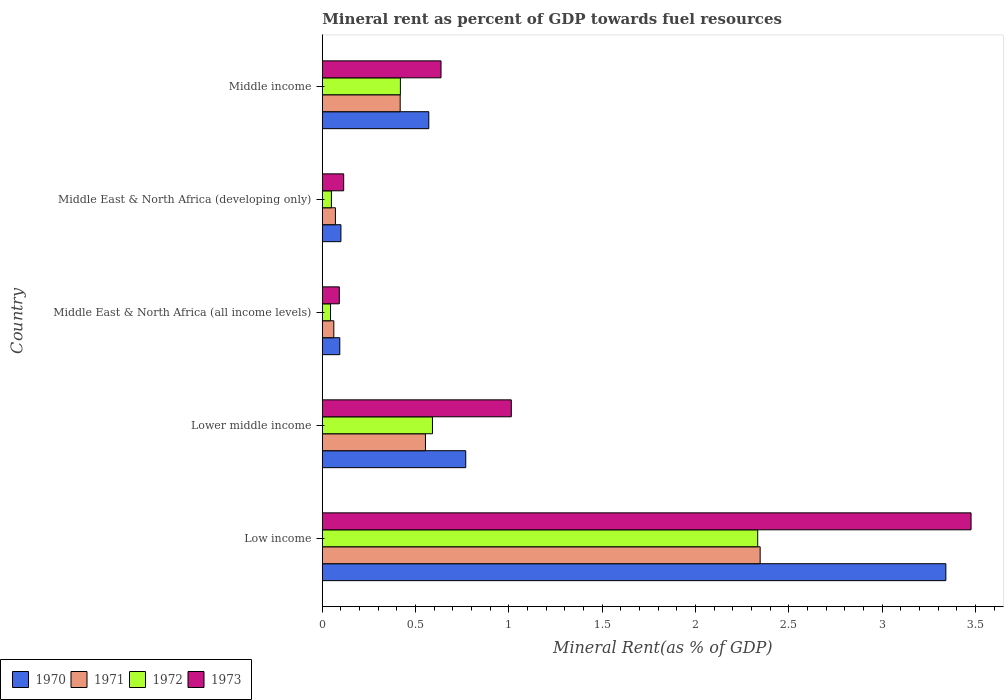How many different coloured bars are there?
Your answer should be very brief. 4. How many bars are there on the 5th tick from the top?
Offer a terse response. 4. How many bars are there on the 1st tick from the bottom?
Offer a very short reply. 4. What is the label of the 3rd group of bars from the top?
Keep it short and to the point. Middle East & North Africa (all income levels). In how many cases, is the number of bars for a given country not equal to the number of legend labels?
Offer a very short reply. 0. What is the mineral rent in 1970 in Middle East & North Africa (all income levels)?
Your answer should be very brief. 0.09. Across all countries, what is the maximum mineral rent in 1972?
Your answer should be very brief. 2.33. Across all countries, what is the minimum mineral rent in 1971?
Keep it short and to the point. 0.06. In which country was the mineral rent in 1972 minimum?
Keep it short and to the point. Middle East & North Africa (all income levels). What is the total mineral rent in 1970 in the graph?
Offer a terse response. 4.87. What is the difference between the mineral rent in 1970 in Lower middle income and that in Middle East & North Africa (all income levels)?
Give a very brief answer. 0.67. What is the difference between the mineral rent in 1971 in Middle income and the mineral rent in 1970 in Middle East & North Africa (developing only)?
Offer a terse response. 0.32. What is the average mineral rent in 1970 per country?
Your answer should be very brief. 0.97. What is the difference between the mineral rent in 1972 and mineral rent in 1971 in Lower middle income?
Provide a succinct answer. 0.04. In how many countries, is the mineral rent in 1971 greater than 0.4 %?
Provide a short and direct response. 3. What is the ratio of the mineral rent in 1973 in Low income to that in Middle East & North Africa (developing only)?
Keep it short and to the point. 30.36. Is the difference between the mineral rent in 1972 in Middle East & North Africa (all income levels) and Middle income greater than the difference between the mineral rent in 1971 in Middle East & North Africa (all income levels) and Middle income?
Provide a succinct answer. No. What is the difference between the highest and the second highest mineral rent in 1972?
Make the answer very short. 1.74. What is the difference between the highest and the lowest mineral rent in 1972?
Your answer should be compact. 2.29. In how many countries, is the mineral rent in 1971 greater than the average mineral rent in 1971 taken over all countries?
Offer a terse response. 1. Is it the case that in every country, the sum of the mineral rent in 1973 and mineral rent in 1970 is greater than the mineral rent in 1972?
Give a very brief answer. Yes. How many countries are there in the graph?
Your response must be concise. 5. What is the difference between two consecutive major ticks on the X-axis?
Offer a terse response. 0.5. How many legend labels are there?
Your answer should be very brief. 4. What is the title of the graph?
Make the answer very short. Mineral rent as percent of GDP towards fuel resources. What is the label or title of the X-axis?
Provide a succinct answer. Mineral Rent(as % of GDP). What is the label or title of the Y-axis?
Make the answer very short. Country. What is the Mineral Rent(as % of GDP) in 1970 in Low income?
Provide a succinct answer. 3.34. What is the Mineral Rent(as % of GDP) of 1971 in Low income?
Offer a terse response. 2.35. What is the Mineral Rent(as % of GDP) of 1972 in Low income?
Your response must be concise. 2.33. What is the Mineral Rent(as % of GDP) in 1973 in Low income?
Provide a succinct answer. 3.48. What is the Mineral Rent(as % of GDP) in 1970 in Lower middle income?
Give a very brief answer. 0.77. What is the Mineral Rent(as % of GDP) in 1971 in Lower middle income?
Your response must be concise. 0.55. What is the Mineral Rent(as % of GDP) of 1972 in Lower middle income?
Your answer should be very brief. 0.59. What is the Mineral Rent(as % of GDP) of 1973 in Lower middle income?
Ensure brevity in your answer.  1.01. What is the Mineral Rent(as % of GDP) of 1970 in Middle East & North Africa (all income levels)?
Your answer should be very brief. 0.09. What is the Mineral Rent(as % of GDP) of 1971 in Middle East & North Africa (all income levels)?
Your response must be concise. 0.06. What is the Mineral Rent(as % of GDP) of 1972 in Middle East & North Africa (all income levels)?
Give a very brief answer. 0.04. What is the Mineral Rent(as % of GDP) in 1973 in Middle East & North Africa (all income levels)?
Make the answer very short. 0.09. What is the Mineral Rent(as % of GDP) in 1970 in Middle East & North Africa (developing only)?
Ensure brevity in your answer.  0.1. What is the Mineral Rent(as % of GDP) of 1971 in Middle East & North Africa (developing only)?
Your answer should be very brief. 0.07. What is the Mineral Rent(as % of GDP) in 1972 in Middle East & North Africa (developing only)?
Your answer should be compact. 0.05. What is the Mineral Rent(as % of GDP) of 1973 in Middle East & North Africa (developing only)?
Provide a short and direct response. 0.11. What is the Mineral Rent(as % of GDP) in 1970 in Middle income?
Provide a short and direct response. 0.57. What is the Mineral Rent(as % of GDP) of 1971 in Middle income?
Give a very brief answer. 0.42. What is the Mineral Rent(as % of GDP) in 1972 in Middle income?
Offer a very short reply. 0.42. What is the Mineral Rent(as % of GDP) in 1973 in Middle income?
Make the answer very short. 0.64. Across all countries, what is the maximum Mineral Rent(as % of GDP) in 1970?
Provide a succinct answer. 3.34. Across all countries, what is the maximum Mineral Rent(as % of GDP) in 1971?
Provide a succinct answer. 2.35. Across all countries, what is the maximum Mineral Rent(as % of GDP) of 1972?
Offer a terse response. 2.33. Across all countries, what is the maximum Mineral Rent(as % of GDP) in 1973?
Ensure brevity in your answer.  3.48. Across all countries, what is the minimum Mineral Rent(as % of GDP) of 1970?
Provide a succinct answer. 0.09. Across all countries, what is the minimum Mineral Rent(as % of GDP) in 1971?
Provide a short and direct response. 0.06. Across all countries, what is the minimum Mineral Rent(as % of GDP) of 1972?
Give a very brief answer. 0.04. Across all countries, what is the minimum Mineral Rent(as % of GDP) of 1973?
Your answer should be compact. 0.09. What is the total Mineral Rent(as % of GDP) of 1970 in the graph?
Your answer should be compact. 4.87. What is the total Mineral Rent(as % of GDP) of 1971 in the graph?
Offer a terse response. 3.45. What is the total Mineral Rent(as % of GDP) of 1972 in the graph?
Offer a terse response. 3.43. What is the total Mineral Rent(as % of GDP) of 1973 in the graph?
Your answer should be very brief. 5.33. What is the difference between the Mineral Rent(as % of GDP) in 1970 in Low income and that in Lower middle income?
Ensure brevity in your answer.  2.57. What is the difference between the Mineral Rent(as % of GDP) of 1971 in Low income and that in Lower middle income?
Give a very brief answer. 1.79. What is the difference between the Mineral Rent(as % of GDP) in 1972 in Low income and that in Lower middle income?
Provide a short and direct response. 1.74. What is the difference between the Mineral Rent(as % of GDP) of 1973 in Low income and that in Lower middle income?
Your response must be concise. 2.46. What is the difference between the Mineral Rent(as % of GDP) of 1970 in Low income and that in Middle East & North Africa (all income levels)?
Give a very brief answer. 3.25. What is the difference between the Mineral Rent(as % of GDP) in 1971 in Low income and that in Middle East & North Africa (all income levels)?
Your answer should be very brief. 2.28. What is the difference between the Mineral Rent(as % of GDP) of 1972 in Low income and that in Middle East & North Africa (all income levels)?
Provide a short and direct response. 2.29. What is the difference between the Mineral Rent(as % of GDP) of 1973 in Low income and that in Middle East & North Africa (all income levels)?
Keep it short and to the point. 3.39. What is the difference between the Mineral Rent(as % of GDP) of 1970 in Low income and that in Middle East & North Africa (developing only)?
Give a very brief answer. 3.24. What is the difference between the Mineral Rent(as % of GDP) in 1971 in Low income and that in Middle East & North Africa (developing only)?
Provide a succinct answer. 2.28. What is the difference between the Mineral Rent(as % of GDP) in 1972 in Low income and that in Middle East & North Africa (developing only)?
Your response must be concise. 2.28. What is the difference between the Mineral Rent(as % of GDP) of 1973 in Low income and that in Middle East & North Africa (developing only)?
Provide a succinct answer. 3.36. What is the difference between the Mineral Rent(as % of GDP) of 1970 in Low income and that in Middle income?
Your answer should be very brief. 2.77. What is the difference between the Mineral Rent(as % of GDP) of 1971 in Low income and that in Middle income?
Your answer should be compact. 1.93. What is the difference between the Mineral Rent(as % of GDP) in 1972 in Low income and that in Middle income?
Your response must be concise. 1.91. What is the difference between the Mineral Rent(as % of GDP) in 1973 in Low income and that in Middle income?
Your answer should be very brief. 2.84. What is the difference between the Mineral Rent(as % of GDP) in 1970 in Lower middle income and that in Middle East & North Africa (all income levels)?
Give a very brief answer. 0.67. What is the difference between the Mineral Rent(as % of GDP) of 1971 in Lower middle income and that in Middle East & North Africa (all income levels)?
Offer a terse response. 0.49. What is the difference between the Mineral Rent(as % of GDP) in 1972 in Lower middle income and that in Middle East & North Africa (all income levels)?
Offer a terse response. 0.55. What is the difference between the Mineral Rent(as % of GDP) of 1973 in Lower middle income and that in Middle East & North Africa (all income levels)?
Ensure brevity in your answer.  0.92. What is the difference between the Mineral Rent(as % of GDP) of 1970 in Lower middle income and that in Middle East & North Africa (developing only)?
Make the answer very short. 0.67. What is the difference between the Mineral Rent(as % of GDP) of 1971 in Lower middle income and that in Middle East & North Africa (developing only)?
Your response must be concise. 0.48. What is the difference between the Mineral Rent(as % of GDP) of 1972 in Lower middle income and that in Middle East & North Africa (developing only)?
Ensure brevity in your answer.  0.54. What is the difference between the Mineral Rent(as % of GDP) of 1973 in Lower middle income and that in Middle East & North Africa (developing only)?
Provide a succinct answer. 0.9. What is the difference between the Mineral Rent(as % of GDP) of 1970 in Lower middle income and that in Middle income?
Ensure brevity in your answer.  0.2. What is the difference between the Mineral Rent(as % of GDP) of 1971 in Lower middle income and that in Middle income?
Your answer should be compact. 0.14. What is the difference between the Mineral Rent(as % of GDP) in 1972 in Lower middle income and that in Middle income?
Provide a short and direct response. 0.17. What is the difference between the Mineral Rent(as % of GDP) of 1973 in Lower middle income and that in Middle income?
Ensure brevity in your answer.  0.38. What is the difference between the Mineral Rent(as % of GDP) of 1970 in Middle East & North Africa (all income levels) and that in Middle East & North Africa (developing only)?
Your answer should be very brief. -0.01. What is the difference between the Mineral Rent(as % of GDP) in 1971 in Middle East & North Africa (all income levels) and that in Middle East & North Africa (developing only)?
Provide a succinct answer. -0.01. What is the difference between the Mineral Rent(as % of GDP) in 1972 in Middle East & North Africa (all income levels) and that in Middle East & North Africa (developing only)?
Keep it short and to the point. -0. What is the difference between the Mineral Rent(as % of GDP) of 1973 in Middle East & North Africa (all income levels) and that in Middle East & North Africa (developing only)?
Offer a terse response. -0.02. What is the difference between the Mineral Rent(as % of GDP) in 1970 in Middle East & North Africa (all income levels) and that in Middle income?
Offer a terse response. -0.48. What is the difference between the Mineral Rent(as % of GDP) of 1971 in Middle East & North Africa (all income levels) and that in Middle income?
Your answer should be compact. -0.36. What is the difference between the Mineral Rent(as % of GDP) of 1972 in Middle East & North Africa (all income levels) and that in Middle income?
Offer a very short reply. -0.37. What is the difference between the Mineral Rent(as % of GDP) of 1973 in Middle East & North Africa (all income levels) and that in Middle income?
Offer a very short reply. -0.55. What is the difference between the Mineral Rent(as % of GDP) in 1970 in Middle East & North Africa (developing only) and that in Middle income?
Ensure brevity in your answer.  -0.47. What is the difference between the Mineral Rent(as % of GDP) of 1971 in Middle East & North Africa (developing only) and that in Middle income?
Ensure brevity in your answer.  -0.35. What is the difference between the Mineral Rent(as % of GDP) in 1972 in Middle East & North Africa (developing only) and that in Middle income?
Your answer should be very brief. -0.37. What is the difference between the Mineral Rent(as % of GDP) in 1973 in Middle East & North Africa (developing only) and that in Middle income?
Provide a short and direct response. -0.52. What is the difference between the Mineral Rent(as % of GDP) in 1970 in Low income and the Mineral Rent(as % of GDP) in 1971 in Lower middle income?
Offer a terse response. 2.79. What is the difference between the Mineral Rent(as % of GDP) of 1970 in Low income and the Mineral Rent(as % of GDP) of 1972 in Lower middle income?
Ensure brevity in your answer.  2.75. What is the difference between the Mineral Rent(as % of GDP) in 1970 in Low income and the Mineral Rent(as % of GDP) in 1973 in Lower middle income?
Give a very brief answer. 2.33. What is the difference between the Mineral Rent(as % of GDP) of 1971 in Low income and the Mineral Rent(as % of GDP) of 1972 in Lower middle income?
Ensure brevity in your answer.  1.76. What is the difference between the Mineral Rent(as % of GDP) of 1971 in Low income and the Mineral Rent(as % of GDP) of 1973 in Lower middle income?
Ensure brevity in your answer.  1.33. What is the difference between the Mineral Rent(as % of GDP) in 1972 in Low income and the Mineral Rent(as % of GDP) in 1973 in Lower middle income?
Give a very brief answer. 1.32. What is the difference between the Mineral Rent(as % of GDP) in 1970 in Low income and the Mineral Rent(as % of GDP) in 1971 in Middle East & North Africa (all income levels)?
Keep it short and to the point. 3.28. What is the difference between the Mineral Rent(as % of GDP) in 1970 in Low income and the Mineral Rent(as % of GDP) in 1972 in Middle East & North Africa (all income levels)?
Provide a short and direct response. 3.3. What is the difference between the Mineral Rent(as % of GDP) of 1970 in Low income and the Mineral Rent(as % of GDP) of 1973 in Middle East & North Africa (all income levels)?
Your answer should be compact. 3.25. What is the difference between the Mineral Rent(as % of GDP) in 1971 in Low income and the Mineral Rent(as % of GDP) in 1972 in Middle East & North Africa (all income levels)?
Your answer should be very brief. 2.3. What is the difference between the Mineral Rent(as % of GDP) of 1971 in Low income and the Mineral Rent(as % of GDP) of 1973 in Middle East & North Africa (all income levels)?
Your answer should be very brief. 2.26. What is the difference between the Mineral Rent(as % of GDP) in 1972 in Low income and the Mineral Rent(as % of GDP) in 1973 in Middle East & North Africa (all income levels)?
Your answer should be compact. 2.24. What is the difference between the Mineral Rent(as % of GDP) of 1970 in Low income and the Mineral Rent(as % of GDP) of 1971 in Middle East & North Africa (developing only)?
Provide a short and direct response. 3.27. What is the difference between the Mineral Rent(as % of GDP) in 1970 in Low income and the Mineral Rent(as % of GDP) in 1972 in Middle East & North Africa (developing only)?
Keep it short and to the point. 3.29. What is the difference between the Mineral Rent(as % of GDP) in 1970 in Low income and the Mineral Rent(as % of GDP) in 1973 in Middle East & North Africa (developing only)?
Offer a terse response. 3.23. What is the difference between the Mineral Rent(as % of GDP) of 1971 in Low income and the Mineral Rent(as % of GDP) of 1972 in Middle East & North Africa (developing only)?
Keep it short and to the point. 2.3. What is the difference between the Mineral Rent(as % of GDP) of 1971 in Low income and the Mineral Rent(as % of GDP) of 1973 in Middle East & North Africa (developing only)?
Offer a terse response. 2.23. What is the difference between the Mineral Rent(as % of GDP) in 1972 in Low income and the Mineral Rent(as % of GDP) in 1973 in Middle East & North Africa (developing only)?
Make the answer very short. 2.22. What is the difference between the Mineral Rent(as % of GDP) of 1970 in Low income and the Mineral Rent(as % of GDP) of 1971 in Middle income?
Offer a very short reply. 2.92. What is the difference between the Mineral Rent(as % of GDP) of 1970 in Low income and the Mineral Rent(as % of GDP) of 1972 in Middle income?
Offer a terse response. 2.92. What is the difference between the Mineral Rent(as % of GDP) of 1970 in Low income and the Mineral Rent(as % of GDP) of 1973 in Middle income?
Keep it short and to the point. 2.71. What is the difference between the Mineral Rent(as % of GDP) of 1971 in Low income and the Mineral Rent(as % of GDP) of 1972 in Middle income?
Provide a succinct answer. 1.93. What is the difference between the Mineral Rent(as % of GDP) of 1971 in Low income and the Mineral Rent(as % of GDP) of 1973 in Middle income?
Keep it short and to the point. 1.71. What is the difference between the Mineral Rent(as % of GDP) of 1972 in Low income and the Mineral Rent(as % of GDP) of 1973 in Middle income?
Your answer should be compact. 1.7. What is the difference between the Mineral Rent(as % of GDP) in 1970 in Lower middle income and the Mineral Rent(as % of GDP) in 1971 in Middle East & North Africa (all income levels)?
Your response must be concise. 0.71. What is the difference between the Mineral Rent(as % of GDP) in 1970 in Lower middle income and the Mineral Rent(as % of GDP) in 1972 in Middle East & North Africa (all income levels)?
Ensure brevity in your answer.  0.72. What is the difference between the Mineral Rent(as % of GDP) of 1970 in Lower middle income and the Mineral Rent(as % of GDP) of 1973 in Middle East & North Africa (all income levels)?
Give a very brief answer. 0.68. What is the difference between the Mineral Rent(as % of GDP) in 1971 in Lower middle income and the Mineral Rent(as % of GDP) in 1972 in Middle East & North Africa (all income levels)?
Your answer should be compact. 0.51. What is the difference between the Mineral Rent(as % of GDP) in 1971 in Lower middle income and the Mineral Rent(as % of GDP) in 1973 in Middle East & North Africa (all income levels)?
Keep it short and to the point. 0.46. What is the difference between the Mineral Rent(as % of GDP) in 1972 in Lower middle income and the Mineral Rent(as % of GDP) in 1973 in Middle East & North Africa (all income levels)?
Make the answer very short. 0.5. What is the difference between the Mineral Rent(as % of GDP) of 1970 in Lower middle income and the Mineral Rent(as % of GDP) of 1971 in Middle East & North Africa (developing only)?
Offer a very short reply. 0.7. What is the difference between the Mineral Rent(as % of GDP) of 1970 in Lower middle income and the Mineral Rent(as % of GDP) of 1972 in Middle East & North Africa (developing only)?
Give a very brief answer. 0.72. What is the difference between the Mineral Rent(as % of GDP) of 1970 in Lower middle income and the Mineral Rent(as % of GDP) of 1973 in Middle East & North Africa (developing only)?
Offer a very short reply. 0.65. What is the difference between the Mineral Rent(as % of GDP) in 1971 in Lower middle income and the Mineral Rent(as % of GDP) in 1972 in Middle East & North Africa (developing only)?
Make the answer very short. 0.5. What is the difference between the Mineral Rent(as % of GDP) in 1971 in Lower middle income and the Mineral Rent(as % of GDP) in 1973 in Middle East & North Africa (developing only)?
Provide a succinct answer. 0.44. What is the difference between the Mineral Rent(as % of GDP) in 1972 in Lower middle income and the Mineral Rent(as % of GDP) in 1973 in Middle East & North Africa (developing only)?
Your answer should be compact. 0.48. What is the difference between the Mineral Rent(as % of GDP) of 1970 in Lower middle income and the Mineral Rent(as % of GDP) of 1971 in Middle income?
Provide a short and direct response. 0.35. What is the difference between the Mineral Rent(as % of GDP) of 1970 in Lower middle income and the Mineral Rent(as % of GDP) of 1972 in Middle income?
Ensure brevity in your answer.  0.35. What is the difference between the Mineral Rent(as % of GDP) of 1970 in Lower middle income and the Mineral Rent(as % of GDP) of 1973 in Middle income?
Your answer should be very brief. 0.13. What is the difference between the Mineral Rent(as % of GDP) of 1971 in Lower middle income and the Mineral Rent(as % of GDP) of 1972 in Middle income?
Offer a very short reply. 0.13. What is the difference between the Mineral Rent(as % of GDP) of 1971 in Lower middle income and the Mineral Rent(as % of GDP) of 1973 in Middle income?
Give a very brief answer. -0.08. What is the difference between the Mineral Rent(as % of GDP) of 1972 in Lower middle income and the Mineral Rent(as % of GDP) of 1973 in Middle income?
Keep it short and to the point. -0.05. What is the difference between the Mineral Rent(as % of GDP) of 1970 in Middle East & North Africa (all income levels) and the Mineral Rent(as % of GDP) of 1971 in Middle East & North Africa (developing only)?
Your answer should be compact. 0.02. What is the difference between the Mineral Rent(as % of GDP) of 1970 in Middle East & North Africa (all income levels) and the Mineral Rent(as % of GDP) of 1972 in Middle East & North Africa (developing only)?
Your answer should be very brief. 0.04. What is the difference between the Mineral Rent(as % of GDP) of 1970 in Middle East & North Africa (all income levels) and the Mineral Rent(as % of GDP) of 1973 in Middle East & North Africa (developing only)?
Your response must be concise. -0.02. What is the difference between the Mineral Rent(as % of GDP) in 1971 in Middle East & North Africa (all income levels) and the Mineral Rent(as % of GDP) in 1972 in Middle East & North Africa (developing only)?
Your answer should be compact. 0.01. What is the difference between the Mineral Rent(as % of GDP) in 1971 in Middle East & North Africa (all income levels) and the Mineral Rent(as % of GDP) in 1973 in Middle East & North Africa (developing only)?
Offer a terse response. -0.05. What is the difference between the Mineral Rent(as % of GDP) in 1972 in Middle East & North Africa (all income levels) and the Mineral Rent(as % of GDP) in 1973 in Middle East & North Africa (developing only)?
Provide a short and direct response. -0.07. What is the difference between the Mineral Rent(as % of GDP) in 1970 in Middle East & North Africa (all income levels) and the Mineral Rent(as % of GDP) in 1971 in Middle income?
Provide a succinct answer. -0.32. What is the difference between the Mineral Rent(as % of GDP) in 1970 in Middle East & North Africa (all income levels) and the Mineral Rent(as % of GDP) in 1972 in Middle income?
Ensure brevity in your answer.  -0.32. What is the difference between the Mineral Rent(as % of GDP) of 1970 in Middle East & North Africa (all income levels) and the Mineral Rent(as % of GDP) of 1973 in Middle income?
Provide a short and direct response. -0.54. What is the difference between the Mineral Rent(as % of GDP) in 1971 in Middle East & North Africa (all income levels) and the Mineral Rent(as % of GDP) in 1972 in Middle income?
Your answer should be compact. -0.36. What is the difference between the Mineral Rent(as % of GDP) of 1971 in Middle East & North Africa (all income levels) and the Mineral Rent(as % of GDP) of 1973 in Middle income?
Ensure brevity in your answer.  -0.57. What is the difference between the Mineral Rent(as % of GDP) in 1972 in Middle East & North Africa (all income levels) and the Mineral Rent(as % of GDP) in 1973 in Middle income?
Give a very brief answer. -0.59. What is the difference between the Mineral Rent(as % of GDP) of 1970 in Middle East & North Africa (developing only) and the Mineral Rent(as % of GDP) of 1971 in Middle income?
Your answer should be very brief. -0.32. What is the difference between the Mineral Rent(as % of GDP) of 1970 in Middle East & North Africa (developing only) and the Mineral Rent(as % of GDP) of 1972 in Middle income?
Provide a short and direct response. -0.32. What is the difference between the Mineral Rent(as % of GDP) of 1970 in Middle East & North Africa (developing only) and the Mineral Rent(as % of GDP) of 1973 in Middle income?
Your answer should be very brief. -0.54. What is the difference between the Mineral Rent(as % of GDP) in 1971 in Middle East & North Africa (developing only) and the Mineral Rent(as % of GDP) in 1972 in Middle income?
Your answer should be compact. -0.35. What is the difference between the Mineral Rent(as % of GDP) in 1971 in Middle East & North Africa (developing only) and the Mineral Rent(as % of GDP) in 1973 in Middle income?
Give a very brief answer. -0.57. What is the difference between the Mineral Rent(as % of GDP) of 1972 in Middle East & North Africa (developing only) and the Mineral Rent(as % of GDP) of 1973 in Middle income?
Offer a very short reply. -0.59. What is the average Mineral Rent(as % of GDP) of 1970 per country?
Your answer should be very brief. 0.97. What is the average Mineral Rent(as % of GDP) in 1971 per country?
Your response must be concise. 0.69. What is the average Mineral Rent(as % of GDP) in 1972 per country?
Offer a terse response. 0.69. What is the average Mineral Rent(as % of GDP) in 1973 per country?
Offer a very short reply. 1.07. What is the difference between the Mineral Rent(as % of GDP) of 1970 and Mineral Rent(as % of GDP) of 1972 in Low income?
Ensure brevity in your answer.  1.01. What is the difference between the Mineral Rent(as % of GDP) in 1970 and Mineral Rent(as % of GDP) in 1973 in Low income?
Give a very brief answer. -0.14. What is the difference between the Mineral Rent(as % of GDP) in 1971 and Mineral Rent(as % of GDP) in 1972 in Low income?
Your answer should be very brief. 0.01. What is the difference between the Mineral Rent(as % of GDP) in 1971 and Mineral Rent(as % of GDP) in 1973 in Low income?
Make the answer very short. -1.13. What is the difference between the Mineral Rent(as % of GDP) of 1972 and Mineral Rent(as % of GDP) of 1973 in Low income?
Give a very brief answer. -1.14. What is the difference between the Mineral Rent(as % of GDP) in 1970 and Mineral Rent(as % of GDP) in 1971 in Lower middle income?
Give a very brief answer. 0.22. What is the difference between the Mineral Rent(as % of GDP) in 1970 and Mineral Rent(as % of GDP) in 1972 in Lower middle income?
Provide a succinct answer. 0.18. What is the difference between the Mineral Rent(as % of GDP) in 1970 and Mineral Rent(as % of GDP) in 1973 in Lower middle income?
Offer a very short reply. -0.24. What is the difference between the Mineral Rent(as % of GDP) in 1971 and Mineral Rent(as % of GDP) in 1972 in Lower middle income?
Your answer should be very brief. -0.04. What is the difference between the Mineral Rent(as % of GDP) in 1971 and Mineral Rent(as % of GDP) in 1973 in Lower middle income?
Ensure brevity in your answer.  -0.46. What is the difference between the Mineral Rent(as % of GDP) of 1972 and Mineral Rent(as % of GDP) of 1973 in Lower middle income?
Ensure brevity in your answer.  -0.42. What is the difference between the Mineral Rent(as % of GDP) of 1970 and Mineral Rent(as % of GDP) of 1971 in Middle East & North Africa (all income levels)?
Your response must be concise. 0.03. What is the difference between the Mineral Rent(as % of GDP) of 1970 and Mineral Rent(as % of GDP) of 1972 in Middle East & North Africa (all income levels)?
Your answer should be very brief. 0.05. What is the difference between the Mineral Rent(as % of GDP) of 1970 and Mineral Rent(as % of GDP) of 1973 in Middle East & North Africa (all income levels)?
Provide a short and direct response. 0. What is the difference between the Mineral Rent(as % of GDP) of 1971 and Mineral Rent(as % of GDP) of 1972 in Middle East & North Africa (all income levels)?
Your answer should be very brief. 0.02. What is the difference between the Mineral Rent(as % of GDP) in 1971 and Mineral Rent(as % of GDP) in 1973 in Middle East & North Africa (all income levels)?
Offer a very short reply. -0.03. What is the difference between the Mineral Rent(as % of GDP) of 1972 and Mineral Rent(as % of GDP) of 1973 in Middle East & North Africa (all income levels)?
Offer a terse response. -0.05. What is the difference between the Mineral Rent(as % of GDP) in 1970 and Mineral Rent(as % of GDP) in 1971 in Middle East & North Africa (developing only)?
Your answer should be compact. 0.03. What is the difference between the Mineral Rent(as % of GDP) of 1970 and Mineral Rent(as % of GDP) of 1972 in Middle East & North Africa (developing only)?
Ensure brevity in your answer.  0.05. What is the difference between the Mineral Rent(as % of GDP) in 1970 and Mineral Rent(as % of GDP) in 1973 in Middle East & North Africa (developing only)?
Provide a short and direct response. -0.01. What is the difference between the Mineral Rent(as % of GDP) of 1971 and Mineral Rent(as % of GDP) of 1972 in Middle East & North Africa (developing only)?
Provide a short and direct response. 0.02. What is the difference between the Mineral Rent(as % of GDP) of 1971 and Mineral Rent(as % of GDP) of 1973 in Middle East & North Africa (developing only)?
Your response must be concise. -0.04. What is the difference between the Mineral Rent(as % of GDP) of 1972 and Mineral Rent(as % of GDP) of 1973 in Middle East & North Africa (developing only)?
Provide a short and direct response. -0.07. What is the difference between the Mineral Rent(as % of GDP) in 1970 and Mineral Rent(as % of GDP) in 1971 in Middle income?
Provide a short and direct response. 0.15. What is the difference between the Mineral Rent(as % of GDP) in 1970 and Mineral Rent(as % of GDP) in 1972 in Middle income?
Provide a short and direct response. 0.15. What is the difference between the Mineral Rent(as % of GDP) in 1970 and Mineral Rent(as % of GDP) in 1973 in Middle income?
Your answer should be very brief. -0.07. What is the difference between the Mineral Rent(as % of GDP) of 1971 and Mineral Rent(as % of GDP) of 1972 in Middle income?
Make the answer very short. -0. What is the difference between the Mineral Rent(as % of GDP) in 1971 and Mineral Rent(as % of GDP) in 1973 in Middle income?
Your answer should be very brief. -0.22. What is the difference between the Mineral Rent(as % of GDP) in 1972 and Mineral Rent(as % of GDP) in 1973 in Middle income?
Keep it short and to the point. -0.22. What is the ratio of the Mineral Rent(as % of GDP) in 1970 in Low income to that in Lower middle income?
Your answer should be compact. 4.35. What is the ratio of the Mineral Rent(as % of GDP) in 1971 in Low income to that in Lower middle income?
Your answer should be very brief. 4.25. What is the ratio of the Mineral Rent(as % of GDP) in 1972 in Low income to that in Lower middle income?
Provide a short and direct response. 3.95. What is the ratio of the Mineral Rent(as % of GDP) of 1973 in Low income to that in Lower middle income?
Give a very brief answer. 3.43. What is the ratio of the Mineral Rent(as % of GDP) in 1970 in Low income to that in Middle East & North Africa (all income levels)?
Offer a terse response. 35.68. What is the ratio of the Mineral Rent(as % of GDP) of 1971 in Low income to that in Middle East & North Africa (all income levels)?
Ensure brevity in your answer.  38.13. What is the ratio of the Mineral Rent(as % of GDP) of 1972 in Low income to that in Middle East & North Africa (all income levels)?
Your answer should be compact. 53.05. What is the ratio of the Mineral Rent(as % of GDP) of 1973 in Low income to that in Middle East & North Africa (all income levels)?
Your response must be concise. 38.18. What is the ratio of the Mineral Rent(as % of GDP) in 1970 in Low income to that in Middle East & North Africa (developing only)?
Your answer should be compact. 33.55. What is the ratio of the Mineral Rent(as % of GDP) in 1971 in Low income to that in Middle East & North Africa (developing only)?
Your response must be concise. 33.42. What is the ratio of the Mineral Rent(as % of GDP) of 1972 in Low income to that in Middle East & North Africa (developing only)?
Make the answer very short. 47.95. What is the ratio of the Mineral Rent(as % of GDP) of 1973 in Low income to that in Middle East & North Africa (developing only)?
Keep it short and to the point. 30.36. What is the ratio of the Mineral Rent(as % of GDP) of 1970 in Low income to that in Middle income?
Provide a short and direct response. 5.86. What is the ratio of the Mineral Rent(as % of GDP) of 1971 in Low income to that in Middle income?
Provide a short and direct response. 5.62. What is the ratio of the Mineral Rent(as % of GDP) in 1972 in Low income to that in Middle income?
Ensure brevity in your answer.  5.58. What is the ratio of the Mineral Rent(as % of GDP) of 1973 in Low income to that in Middle income?
Provide a succinct answer. 5.47. What is the ratio of the Mineral Rent(as % of GDP) in 1970 in Lower middle income to that in Middle East & North Africa (all income levels)?
Make the answer very short. 8.21. What is the ratio of the Mineral Rent(as % of GDP) in 1971 in Lower middle income to that in Middle East & North Africa (all income levels)?
Keep it short and to the point. 8.98. What is the ratio of the Mineral Rent(as % of GDP) in 1972 in Lower middle income to that in Middle East & North Africa (all income levels)?
Make the answer very short. 13.42. What is the ratio of the Mineral Rent(as % of GDP) of 1973 in Lower middle income to that in Middle East & North Africa (all income levels)?
Your response must be concise. 11.12. What is the ratio of the Mineral Rent(as % of GDP) in 1970 in Lower middle income to that in Middle East & North Africa (developing only)?
Provide a short and direct response. 7.72. What is the ratio of the Mineral Rent(as % of GDP) in 1971 in Lower middle income to that in Middle East & North Africa (developing only)?
Your answer should be compact. 7.87. What is the ratio of the Mineral Rent(as % of GDP) of 1972 in Lower middle income to that in Middle East & North Africa (developing only)?
Make the answer very short. 12.13. What is the ratio of the Mineral Rent(as % of GDP) in 1973 in Lower middle income to that in Middle East & North Africa (developing only)?
Ensure brevity in your answer.  8.85. What is the ratio of the Mineral Rent(as % of GDP) in 1970 in Lower middle income to that in Middle income?
Offer a terse response. 1.35. What is the ratio of the Mineral Rent(as % of GDP) in 1971 in Lower middle income to that in Middle income?
Provide a short and direct response. 1.32. What is the ratio of the Mineral Rent(as % of GDP) of 1972 in Lower middle income to that in Middle income?
Offer a terse response. 1.41. What is the ratio of the Mineral Rent(as % of GDP) of 1973 in Lower middle income to that in Middle income?
Provide a succinct answer. 1.59. What is the ratio of the Mineral Rent(as % of GDP) in 1970 in Middle East & North Africa (all income levels) to that in Middle East & North Africa (developing only)?
Your response must be concise. 0.94. What is the ratio of the Mineral Rent(as % of GDP) in 1971 in Middle East & North Africa (all income levels) to that in Middle East & North Africa (developing only)?
Provide a short and direct response. 0.88. What is the ratio of the Mineral Rent(as % of GDP) of 1972 in Middle East & North Africa (all income levels) to that in Middle East & North Africa (developing only)?
Your answer should be compact. 0.9. What is the ratio of the Mineral Rent(as % of GDP) of 1973 in Middle East & North Africa (all income levels) to that in Middle East & North Africa (developing only)?
Your response must be concise. 0.8. What is the ratio of the Mineral Rent(as % of GDP) in 1970 in Middle East & North Africa (all income levels) to that in Middle income?
Keep it short and to the point. 0.16. What is the ratio of the Mineral Rent(as % of GDP) of 1971 in Middle East & North Africa (all income levels) to that in Middle income?
Give a very brief answer. 0.15. What is the ratio of the Mineral Rent(as % of GDP) of 1972 in Middle East & North Africa (all income levels) to that in Middle income?
Make the answer very short. 0.11. What is the ratio of the Mineral Rent(as % of GDP) of 1973 in Middle East & North Africa (all income levels) to that in Middle income?
Provide a short and direct response. 0.14. What is the ratio of the Mineral Rent(as % of GDP) in 1970 in Middle East & North Africa (developing only) to that in Middle income?
Ensure brevity in your answer.  0.17. What is the ratio of the Mineral Rent(as % of GDP) in 1971 in Middle East & North Africa (developing only) to that in Middle income?
Offer a terse response. 0.17. What is the ratio of the Mineral Rent(as % of GDP) of 1972 in Middle East & North Africa (developing only) to that in Middle income?
Your answer should be compact. 0.12. What is the ratio of the Mineral Rent(as % of GDP) in 1973 in Middle East & North Africa (developing only) to that in Middle income?
Your answer should be very brief. 0.18. What is the difference between the highest and the second highest Mineral Rent(as % of GDP) in 1970?
Make the answer very short. 2.57. What is the difference between the highest and the second highest Mineral Rent(as % of GDP) in 1971?
Offer a very short reply. 1.79. What is the difference between the highest and the second highest Mineral Rent(as % of GDP) of 1972?
Offer a terse response. 1.74. What is the difference between the highest and the second highest Mineral Rent(as % of GDP) in 1973?
Keep it short and to the point. 2.46. What is the difference between the highest and the lowest Mineral Rent(as % of GDP) of 1970?
Offer a very short reply. 3.25. What is the difference between the highest and the lowest Mineral Rent(as % of GDP) of 1971?
Make the answer very short. 2.28. What is the difference between the highest and the lowest Mineral Rent(as % of GDP) in 1972?
Make the answer very short. 2.29. What is the difference between the highest and the lowest Mineral Rent(as % of GDP) in 1973?
Your answer should be compact. 3.39. 